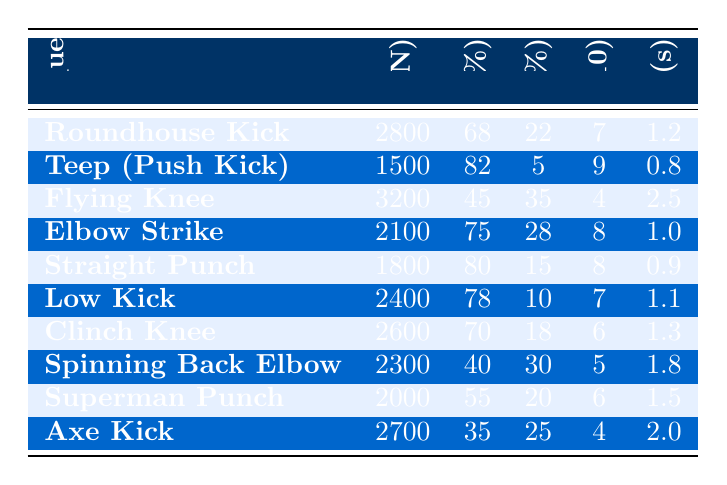What is the striking technique with the highest average impact force? The table shows the average impact force for each striking technique. The "Flying Knee" has the highest value, which is 3200 Newtons.
Answer: Flying Knee Which striking technique has the best success rate? By comparing the success rates across all techniques, the "Teep (Push Kick)" has the highest success rate at 82%.
Answer: Teep (Push Kick) What is the recovery time for the "Roundhouse Kick"? The table lists the recovery time for each technique, showing that the recovery time for the "Roundhouse Kick" is 1.2 seconds.
Answer: 1.2 seconds Which technique has the lowest KO potential percentage? The "Teep (Push Kick)" has the lowest KO potential percentage at 5% when compared to the rest of the techniques listed.
Answer: Teep (Push Kick) Calculate the average energy efficiency of all striking techniques. Summing the energy efficiency values (7 + 9 + 4 + 8 + 8 + 7 + 6 + 5 + 6 + 4) = 64. Since there are 10 techniques, we divide 64 by 10, which equals 6.4.
Answer: 6.4 Is the "Spinning Back Elbow" more energy efficient than the "Straight Punch"? The energy efficiency of the "Spinning Back Elbow" is 5, while the "Straight Punch" has an efficiency of 8. Since 5 is less than 8, the "Spinning Back Elbow" is less efficient.
Answer: No How does the average impact force of the "Superman Punch" compare to the "Low Kick"? The "Superman Punch" has an average impact force of 2000 Newtons, while the "Low Kick" shows 2400 Newtons. Comparing these values shows 2000 is less than 2400.
Answer: Superman Punch is less Which striking technique strikes the best balance of high KO potential and success rate? The "Elbow Strike" has a KO potential of 28% and a success rate of 75%. No other technique has both a higher KO potential and success rate simultaneously when compared.
Answer: Elbow Strike Identify a technique that has a recovery time shorter than 1 second. The "Teep (Push Kick)" has a recovery time of 0.8 seconds, which is less than 1 second.
Answer: Teep (Push Kick) Which technique has the highest KO potential percentage among those with a success rate of less than 50%? Only "Flying Knee" falls into the category with a KO potential of 35% and a success rate of 45%. No other technique has a higher KO potential with a lower success rate.
Answer: Flying Knee 